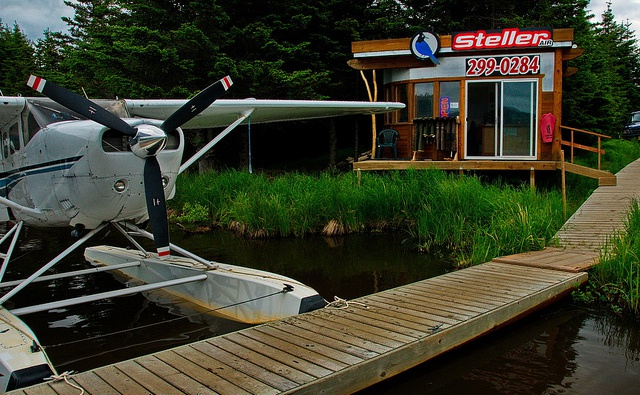Describe the objects in this image and their specific colors. I can see airplane in darkgray, black, and gray tones, car in darkgray, black, gray, and navy tones, and chair in darkgray, black, and teal tones in this image. 